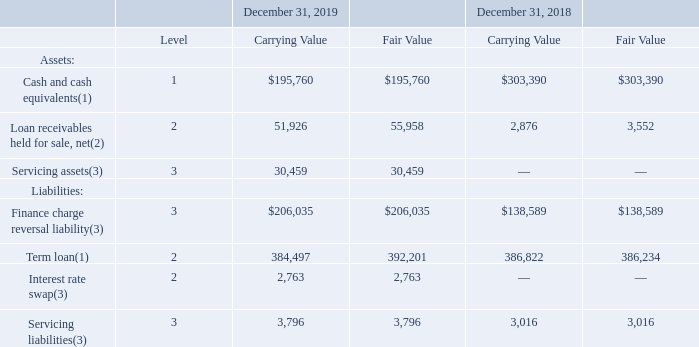GreenSky, Inc. NOTES TO CONSOLIDATED FINANCIAL STATEMENTS — (Continued) (United States Dollars in thousands, except per share data, unless otherwise stated)
Note 3. Fair Value of Assets and Liabilities
The following table summarizes, by level within the fair value hierarchy, the carrying amounts and estimated fair values of our assets and liabilities measured at fair value on a recurring or nonrecurring basis or disclosed, but not carried, at fair value in the Consolidated Balance Sheets as of the dates presented. There were no transfers into, out of, or between levels within the fair value hierarchy during any of the periods presented. Refer to Note 4, Note 7, Note 8, and Note 9 for additional information on these assets and liabilities.
(1) Disclosed, but not carried, at fair value.
(2) Measured at fair value on a nonrecurring basis.
(3) Measured and carried at fair value on a recurring basis.
How was net Loan receivables held for sale measured by the company? At fair value on a nonrecurring basis. What was the carrying value of the term loan in 2019?
Answer scale should be: thousand. 384,497. What was the fair value of the interest rate swap in 2019?
Answer scale should be: thousand. 2,763. How many years did the fair value of Finance charge reversal liability exceed $200,000 thousand? 2019
Answer: 1. What was the change in the carrying value of the term loan between 2018 and 2019?
Answer scale should be: thousand. 384,497-386,822
Answer: -2325. What was the percentage change in the carrying value for Cash and Cash equivalents between 2018 and 2019?
Answer scale should be: percent. (195,760-303,390)/303,390
Answer: -35.48. 